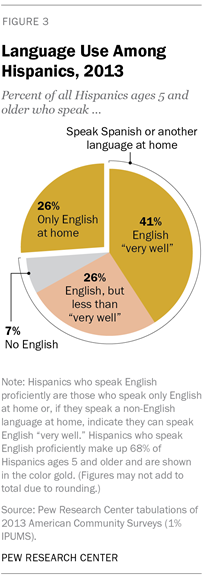Give some essential details in this illustration. The percentage value of the pink segment is 26. The result of subtracting the smallest segment from the average of two yellow segments is 26.5. 